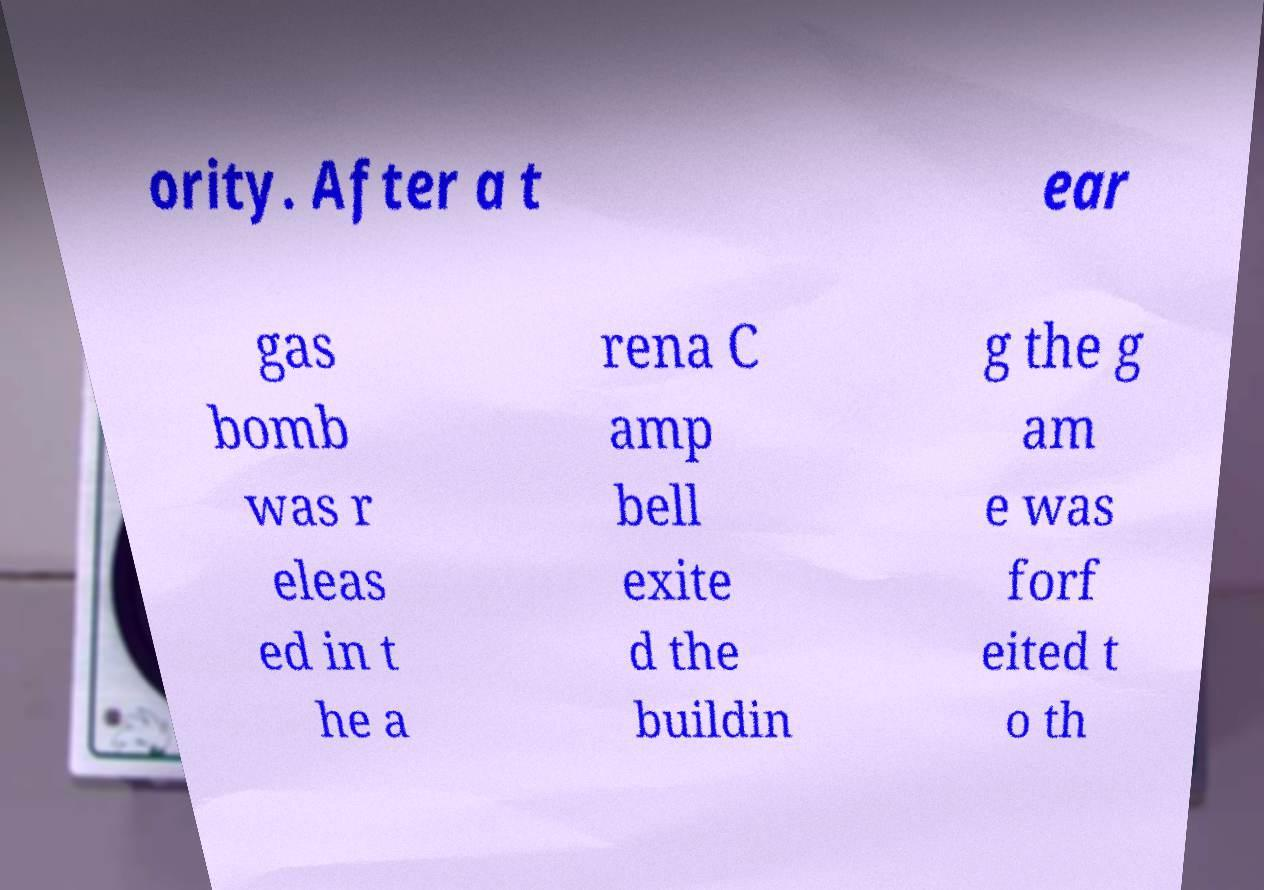Can you read and provide the text displayed in the image?This photo seems to have some interesting text. Can you extract and type it out for me? ority. After a t ear gas bomb was r eleas ed in t he a rena C amp bell exite d the buildin g the g am e was forf eited t o th 